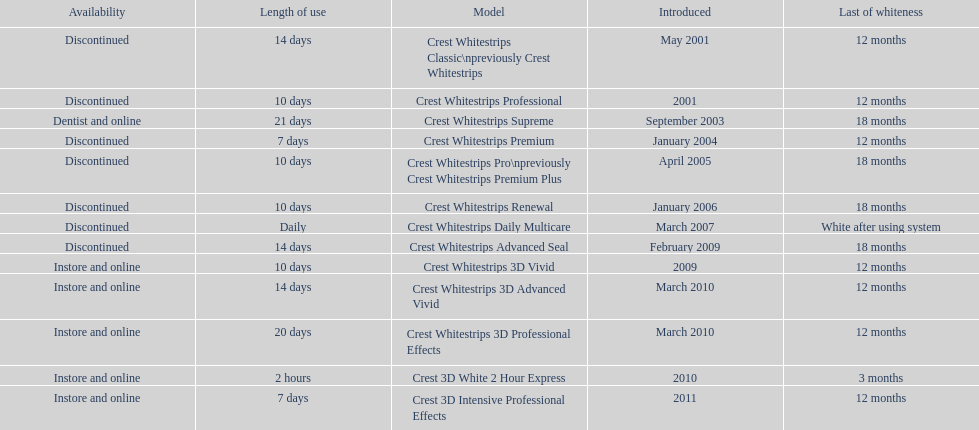Does the crest white strips pro last as long as the crest white strips renewal? Yes. 